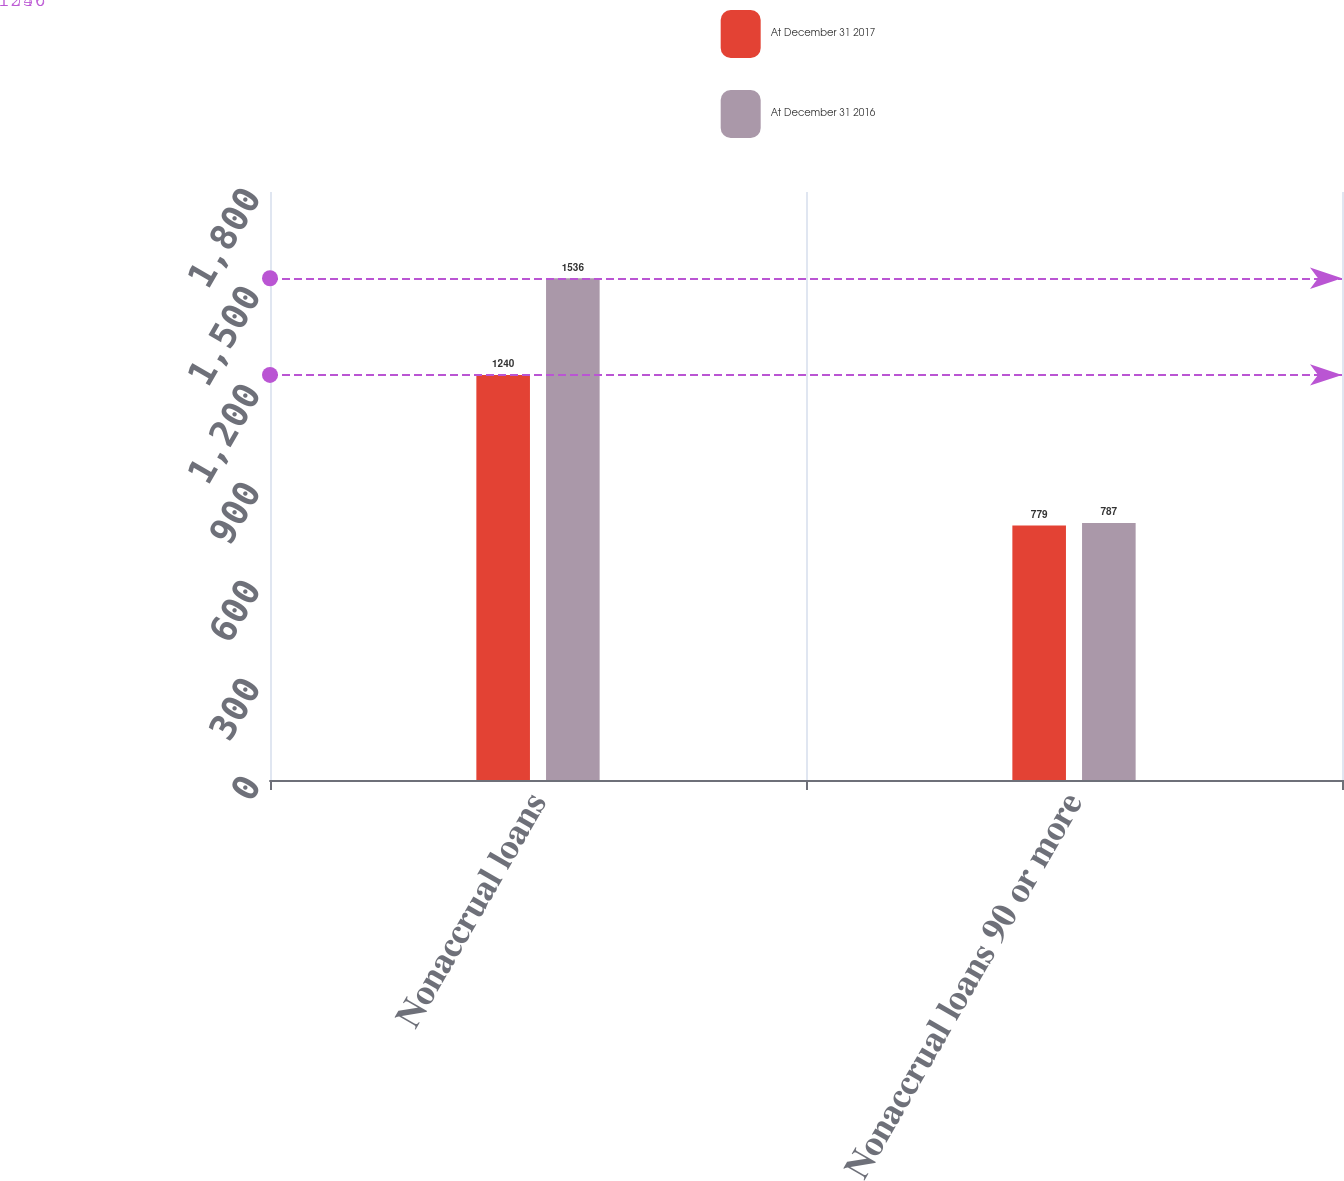<chart> <loc_0><loc_0><loc_500><loc_500><stacked_bar_chart><ecel><fcel>Nonaccrual loans<fcel>Nonaccrual loans 90 or more<nl><fcel>At December 31 2017<fcel>1240<fcel>779<nl><fcel>At December 31 2016<fcel>1536<fcel>787<nl></chart> 